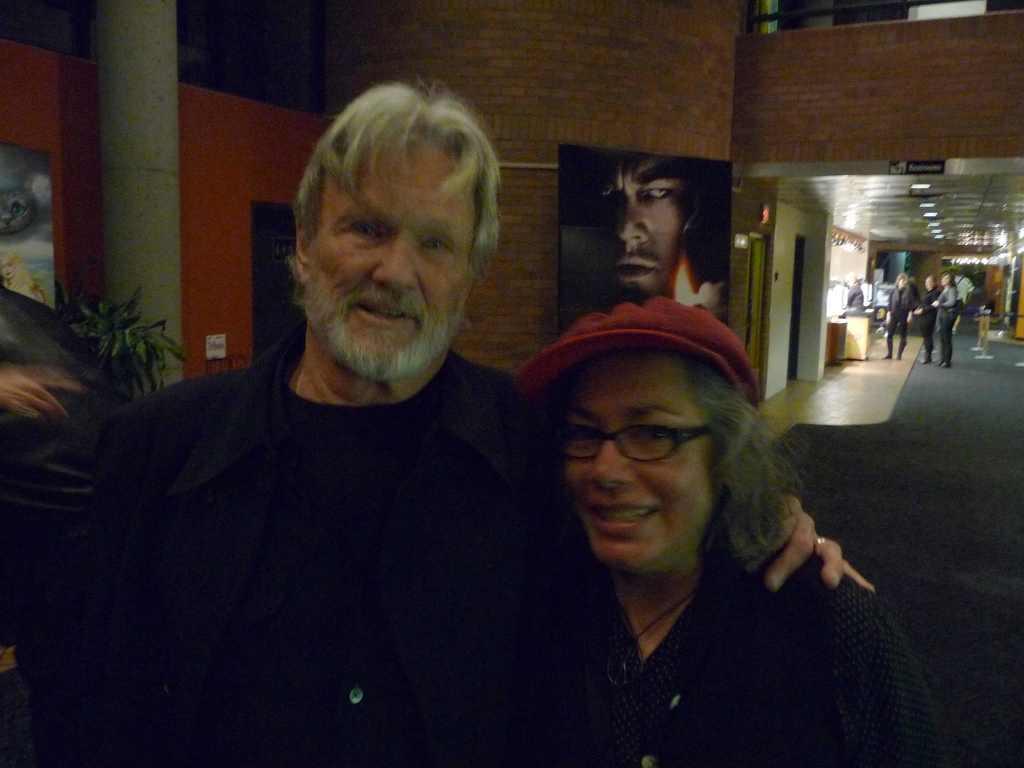In one or two sentences, can you explain what this image depicts? This image consists of two persons in the front. Both are wearing black dress. The woman is wearing a red cap. On the left, we can see a wall along with the pillar. And there are frames on the wall. At the bottom, there is floor mat on the floor. In the background, we can see few people. And we can see a small plant beside the pillar. 